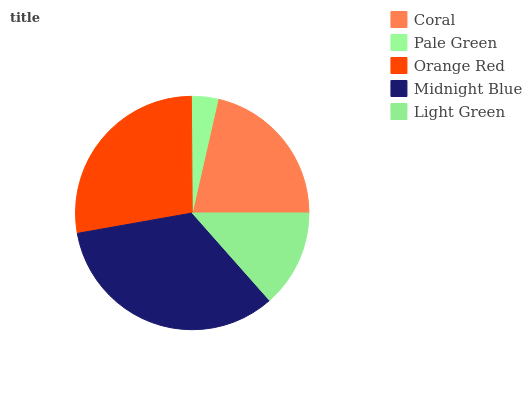Is Pale Green the minimum?
Answer yes or no. Yes. Is Midnight Blue the maximum?
Answer yes or no. Yes. Is Orange Red the minimum?
Answer yes or no. No. Is Orange Red the maximum?
Answer yes or no. No. Is Orange Red greater than Pale Green?
Answer yes or no. Yes. Is Pale Green less than Orange Red?
Answer yes or no. Yes. Is Pale Green greater than Orange Red?
Answer yes or no. No. Is Orange Red less than Pale Green?
Answer yes or no. No. Is Coral the high median?
Answer yes or no. Yes. Is Coral the low median?
Answer yes or no. Yes. Is Orange Red the high median?
Answer yes or no. No. Is Light Green the low median?
Answer yes or no. No. 